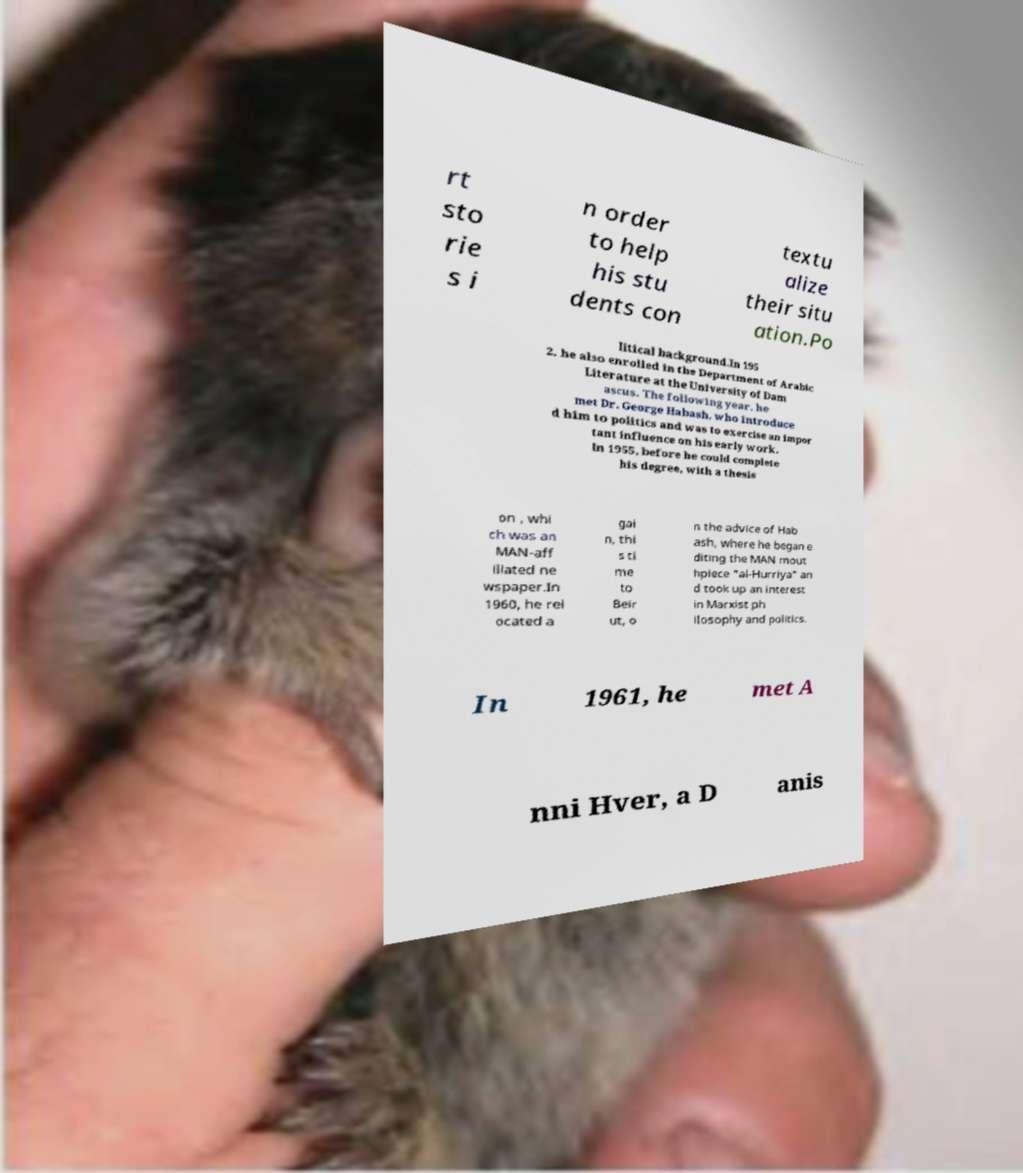For documentation purposes, I need the text within this image transcribed. Could you provide that? rt sto rie s i n order to help his stu dents con textu alize their situ ation.Po litical background.In 195 2, he also enrolled in the Department of Arabic Literature at the University of Dam ascus. The following year, he met Dr. George Habash, who introduce d him to politics and was to exercise an impor tant influence on his early work. In 1955, before he could complete his degree, with a thesis on , whi ch was an MAN-aff iliated ne wspaper.In 1960, he rel ocated a gai n, thi s ti me to Beir ut, o n the advice of Hab ash, where he began e diting the MAN mout hpiece "al-Hurriya" an d took up an interest in Marxist ph ilosophy and politics. In 1961, he met A nni Hver, a D anis 